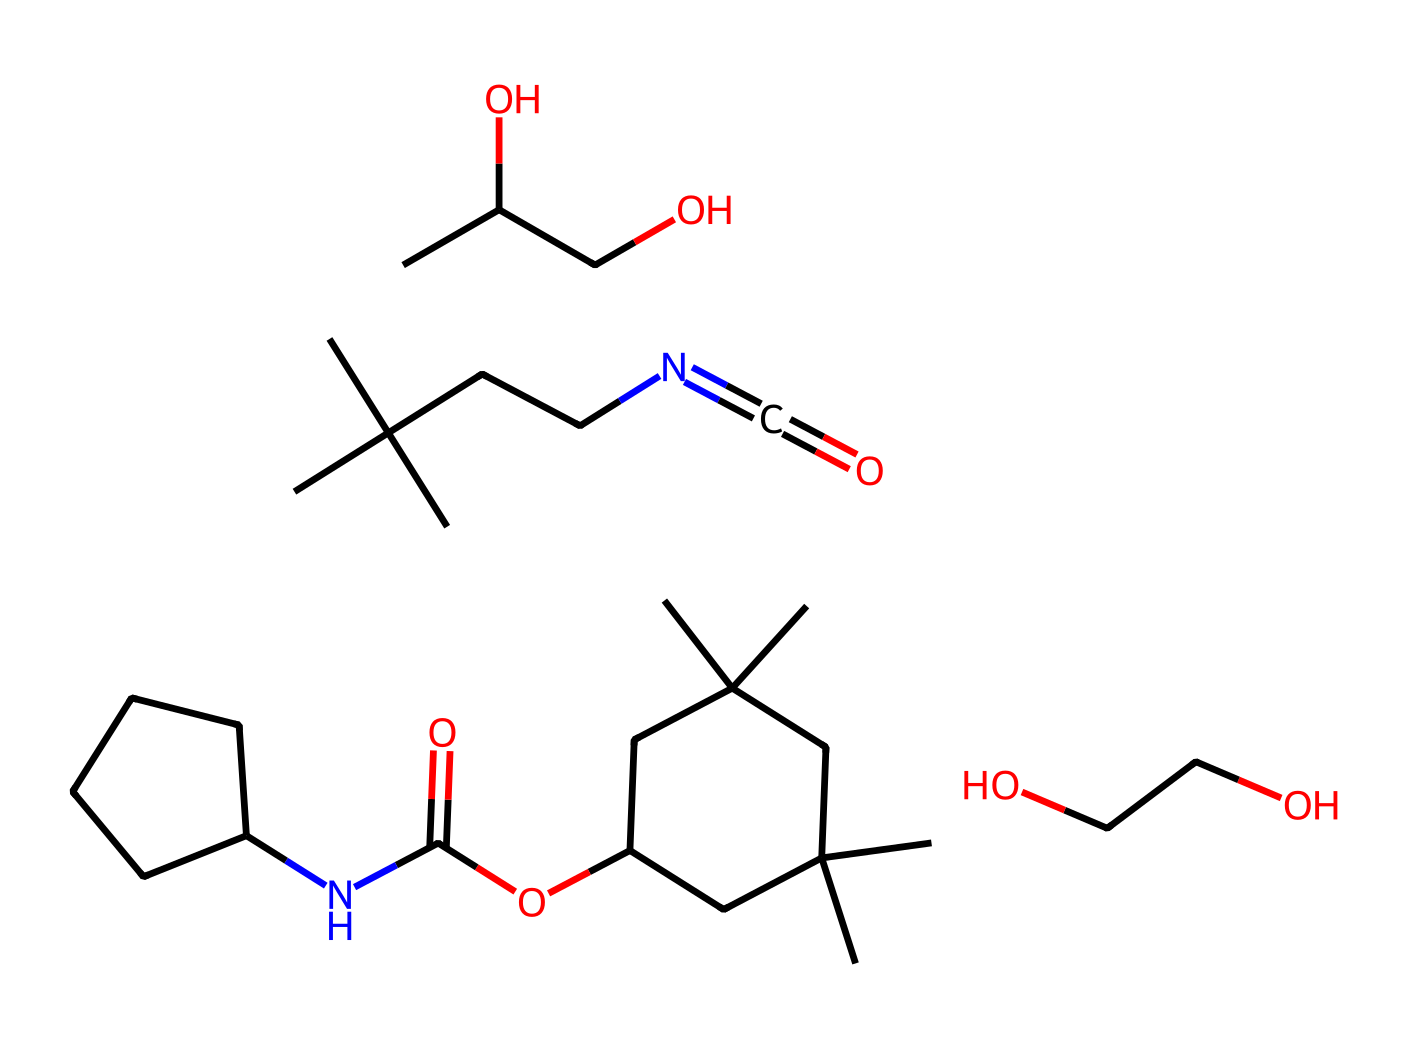what is the primary functional group present in this chemical? The chemical structure contains an isocyanate group (N=C=O) which is a characteristic functional group of polyurethanes.
Answer: isocyanate how many distinct carbon atoms are present in this molecule? In the given SMILES, counting the carbon atoms shows there are 16 distinct carbon atoms.
Answer: 16 what is the role of the hydroxyl groups in this polymer? Hydroxyl groups (-OH) contribute to the polyol component in polyurethane chemistry, enhancing physical properties and aiding polymerization.
Answer: enhance properties what type of polymer structure is formed by this chemical? This chemical primarily forms a segmented polyurethane structure due to the combination of isocyanates and polyols.
Answer: segmented polyurethane how many nitrogen atoms are included in the structure? The structure contains one nitrogen atom as indicated by the presence of the isocyanate functional group (N=C=O).
Answer: 1 what main characteristic does the presence of ether linkages provide to the polymer? Ether linkages in the structure impart flexibility, enhancing the durability and processing characteristics of the final polyurethane foam.
Answer: flexibility which part of the molecule indicates it is intended for ergonomic applications? The presence of the polyol component leading to a soft and resilient foam structure indicates its suitability for ergonomic chairs.
Answer: polyol component 